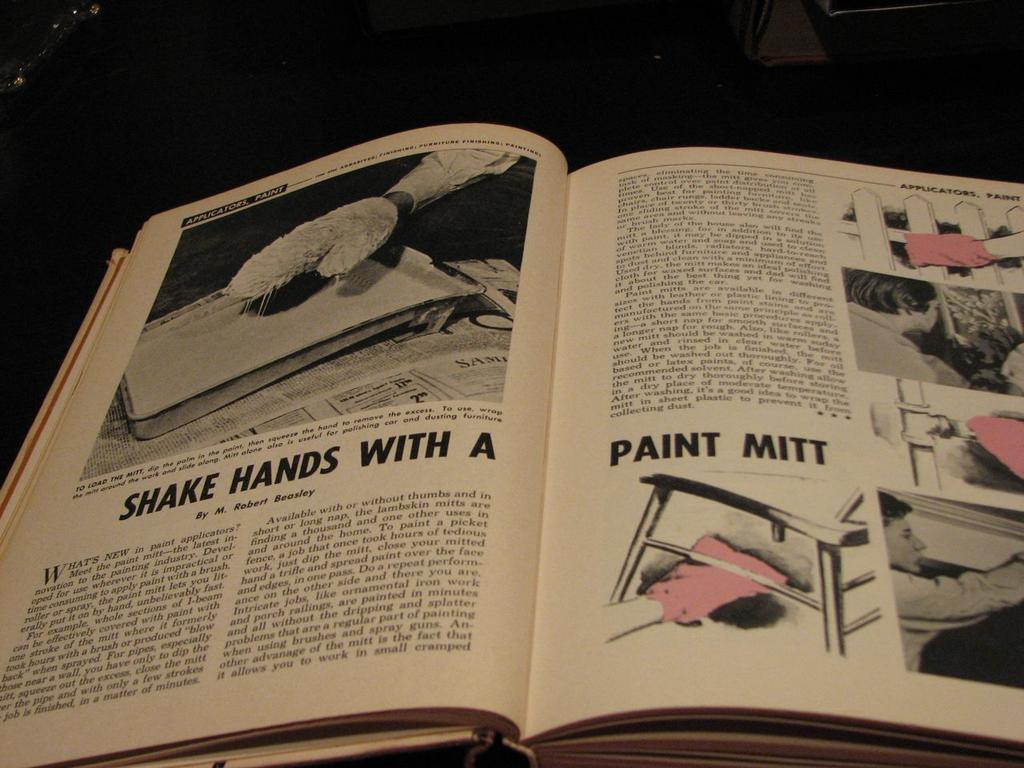Provide a one-sentence caption for the provided image. A book is open to a page with pink Paint Mitts. 